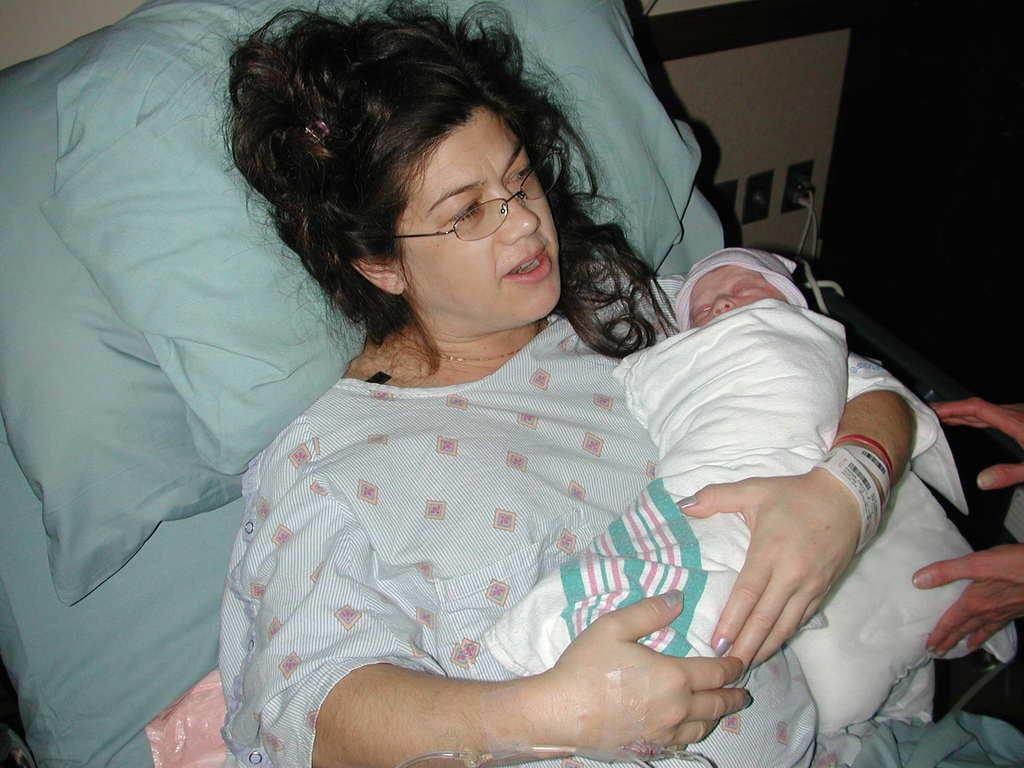What is the woman in the image doing? The woman is on the bed and holding a baby. Can you describe the other person in the image? There is another person in the right corner of the image. What type of fuel is being used by the wheel in the image? There is no wheel or fuel present in the image. 